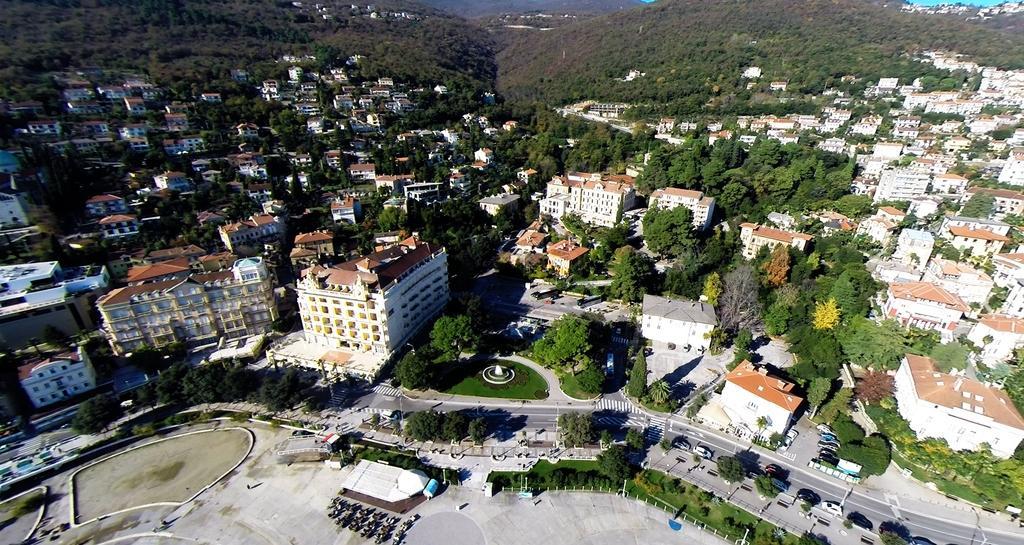Can you describe this image briefly? In the image we can see there are many buildings and trees. Here we can see the road and we can see vehicles on the road. Here we can see the poles, grass, plants and hills. 